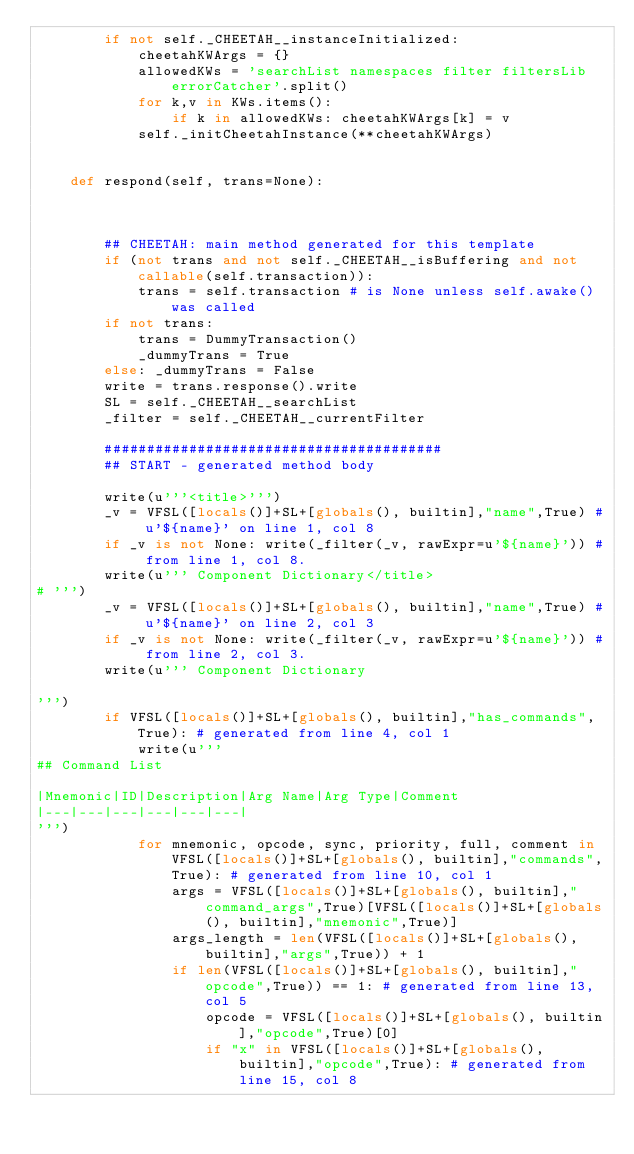Convert code to text. <code><loc_0><loc_0><loc_500><loc_500><_Python_>        if not self._CHEETAH__instanceInitialized:
            cheetahKWArgs = {}
            allowedKWs = 'searchList namespaces filter filtersLib errorCatcher'.split()
            for k,v in KWs.items():
                if k in allowedKWs: cheetahKWArgs[k] = v
            self._initCheetahInstance(**cheetahKWArgs)
        

    def respond(self, trans=None):



        ## CHEETAH: main method generated for this template
        if (not trans and not self._CHEETAH__isBuffering and not callable(self.transaction)):
            trans = self.transaction # is None unless self.awake() was called
        if not trans:
            trans = DummyTransaction()
            _dummyTrans = True
        else: _dummyTrans = False
        write = trans.response().write
        SL = self._CHEETAH__searchList
        _filter = self._CHEETAH__currentFilter
        
        ########################################
        ## START - generated method body
        
        write(u'''<title>''')
        _v = VFSL([locals()]+SL+[globals(), builtin],"name",True) # u'${name}' on line 1, col 8
        if _v is not None: write(_filter(_v, rawExpr=u'${name}')) # from line 1, col 8.
        write(u''' Component Dictionary</title>
# ''')
        _v = VFSL([locals()]+SL+[globals(), builtin],"name",True) # u'${name}' on line 2, col 3
        if _v is not None: write(_filter(_v, rawExpr=u'${name}')) # from line 2, col 3.
        write(u''' Component Dictionary

''')
        if VFSL([locals()]+SL+[globals(), builtin],"has_commands",True): # generated from line 4, col 1
            write(u'''
## Command List

|Mnemonic|ID|Description|Arg Name|Arg Type|Comment
|---|---|---|---|---|---|
''')
            for mnemonic, opcode, sync, priority, full, comment in VFSL([locals()]+SL+[globals(), builtin],"commands",True): # generated from line 10, col 1
                args = VFSL([locals()]+SL+[globals(), builtin],"command_args",True)[VFSL([locals()]+SL+[globals(), builtin],"mnemonic",True)]
                args_length = len(VFSL([locals()]+SL+[globals(), builtin],"args",True)) + 1
                if len(VFSL([locals()]+SL+[globals(), builtin],"opcode",True)) == 1: # generated from line 13, col 5
                    opcode = VFSL([locals()]+SL+[globals(), builtin],"opcode",True)[0]
                    if "x" in VFSL([locals()]+SL+[globals(), builtin],"opcode",True): # generated from line 15, col 8</code> 